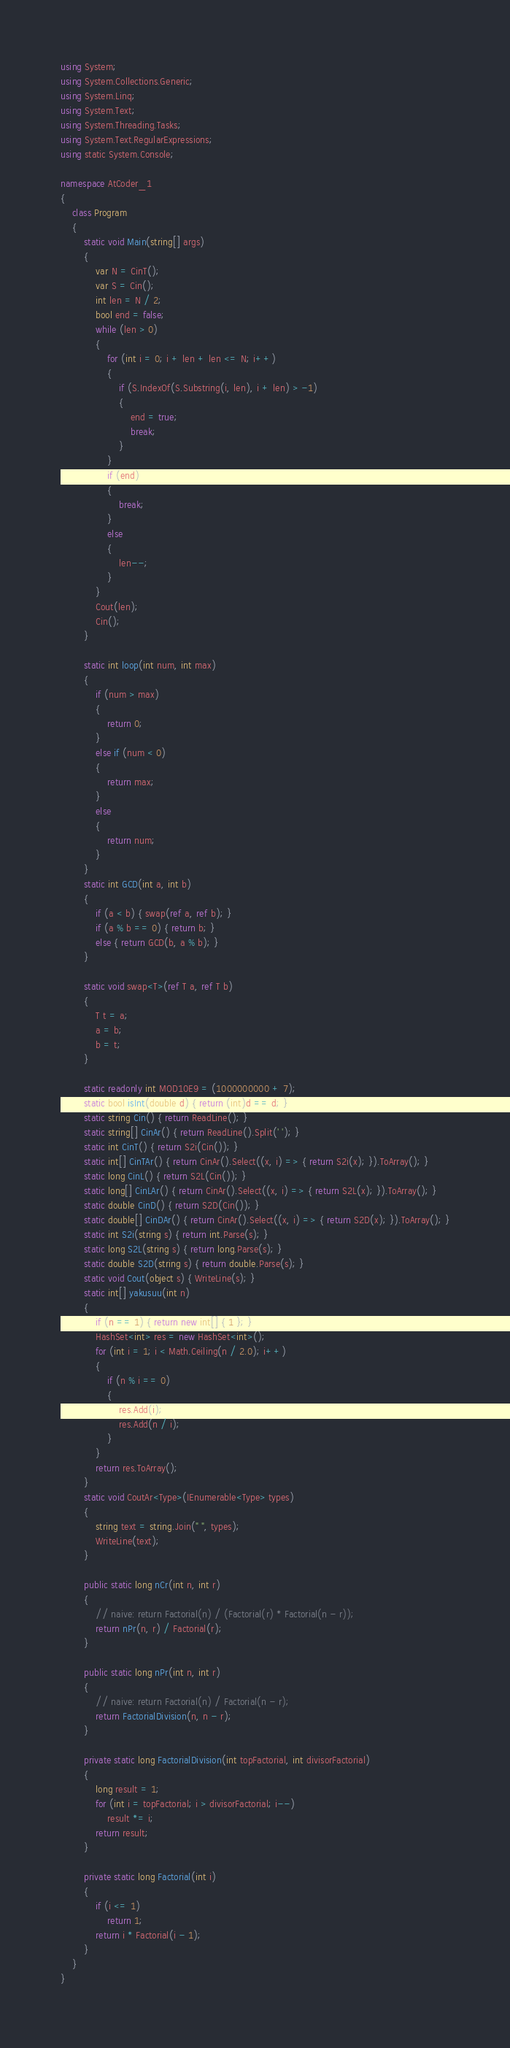Convert code to text. <code><loc_0><loc_0><loc_500><loc_500><_C#_>using System;
using System.Collections.Generic;
using System.Linq;
using System.Text;
using System.Threading.Tasks;
using System.Text.RegularExpressions;
using static System.Console;

namespace AtCoder_1
{
    class Program
    {
        static void Main(string[] args)
        {
            var N = CinT();
            var S = Cin();
            int len = N / 2;
            bool end = false;
            while (len > 0)
            {
                for (int i = 0; i + len + len <= N; i++)
                {
                    if (S.IndexOf(S.Substring(i, len), i + len) > -1)
                    {
                        end = true;
                        break;
                    }
                }
                if (end)
                {
                    break;
                }
                else
                {
                    len--;
                }
            }
            Cout(len);
            Cin();
        }

        static int loop(int num, int max)
        {
            if (num > max)
            {
                return 0;
            }
            else if (num < 0)
            {
                return max;
            }
            else
            {
                return num;
            }
        }
        static int GCD(int a, int b)
        {
            if (a < b) { swap(ref a, ref b); }
            if (a % b == 0) { return b; }
            else { return GCD(b, a % b); }
        }

        static void swap<T>(ref T a, ref T b)
        {
            T t = a;
            a = b;
            b = t;
        }

        static readonly int MOD10E9 = (1000000000 + 7);
        static bool isInt(double d) { return (int)d == d; }
        static string Cin() { return ReadLine(); }
        static string[] CinAr() { return ReadLine().Split(' '); }
        static int CinT() { return S2i(Cin()); }
        static int[] CinTAr() { return CinAr().Select((x, i) => { return S2i(x); }).ToArray(); }
        static long CinL() { return S2L(Cin()); }
        static long[] CinLAr() { return CinAr().Select((x, i) => { return S2L(x); }).ToArray(); }
        static double CinD() { return S2D(Cin()); }
        static double[] CinDAr() { return CinAr().Select((x, i) => { return S2D(x); }).ToArray(); }
        static int S2i(string s) { return int.Parse(s); }
        static long S2L(string s) { return long.Parse(s); }
        static double S2D(string s) { return double.Parse(s); }
        static void Cout(object s) { WriteLine(s); }
        static int[] yakusuu(int n)
        {
            if (n == 1) { return new int[] { 1 }; }
            HashSet<int> res = new HashSet<int>();
            for (int i = 1; i < Math.Ceiling(n / 2.0); i++)
            {
                if (n % i == 0)
                {
                    res.Add(i);
                    res.Add(n / i);
                }
            }
            return res.ToArray();
        }
        static void CoutAr<Type>(IEnumerable<Type> types)
        {
            string text = string.Join(" ", types);
            WriteLine(text);
        }

        public static long nCr(int n, int r)
        {
            // naive: return Factorial(n) / (Factorial(r) * Factorial(n - r));
            return nPr(n, r) / Factorial(r);
        }

        public static long nPr(int n, int r)
        {
            // naive: return Factorial(n) / Factorial(n - r);
            return FactorialDivision(n, n - r);
        }

        private static long FactorialDivision(int topFactorial, int divisorFactorial)
        {
            long result = 1;
            for (int i = topFactorial; i > divisorFactorial; i--)
                result *= i;
            return result;
        }

        private static long Factorial(int i)
        {
            if (i <= 1)
                return 1;
            return i * Factorial(i - 1);
        }
    }
}
</code> 